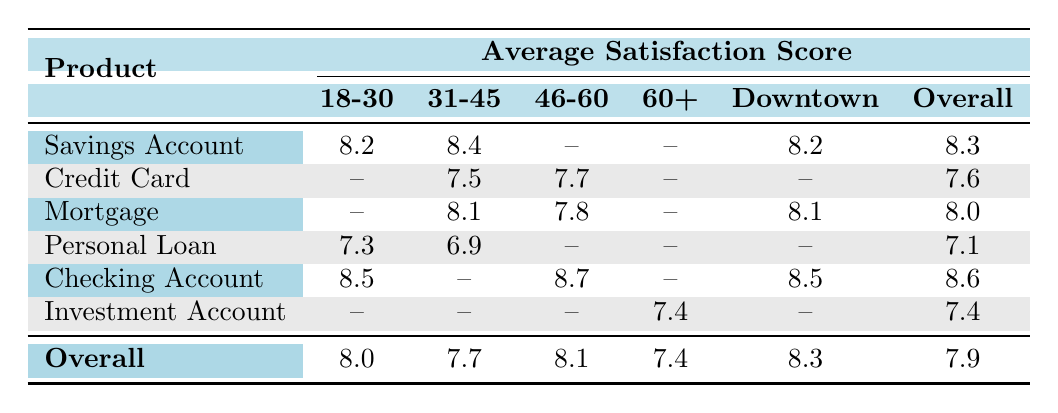What is the average satisfaction score for the Savings Account among the age group 18-30? From the table, the Satisfaction Score for the Savings Account in the age group 18-30 is 8.2. There are no other entries for this product and age group in the dataset. Therefore, the average is simply 8.2.
Answer: 8.2 What is the overall average satisfaction score for the Credit Card? Looking at the Credit Card entries, we see a satisfaction score of 7.5 for the age group 31-45 and 7.7 for the age group 46-60. To find the overall average, we use: (7.5 + 7.7) / 2 = 7.6.
Answer: 7.6 Is the satisfaction score for the Investment Account higher among individuals aged 60+ compared to the overall average? The satisfaction score for the Investment Account for age group 60+ is 7.4. The overall average satisfaction score listed in the table is 7.9. Since 7.4 is less than 7.9, the statement is false.
Answer: No What product has the highest satisfaction score among the age group 46-60? For the age group 46-60, checking the table shows a satisfaction score of 8.7 for Checking Account and 7.8 for Mortgage. Since 8.7 is greater than 7.8, the Checking Account has the highest score.
Answer: Checking Account What is the difference in average satisfaction scores between the age groups 18-30 and 31-45 for the Checking Account? The average satisfaction score for the Checking Account among age group 18-30 is 8.5 and for 31-45, it is not available thus considered as 0. To find the difference, we calculate 8.5 - 0 = 8.5.
Answer: 8.5 